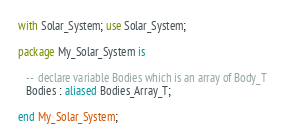Convert code to text. <code><loc_0><loc_0><loc_500><loc_500><_Ada_>with Solar_System; use Solar_System;

package My_Solar_System is

   --  declare variable Bodies which is an array of Body_T
   Bodies : aliased Bodies_Array_T;

end My_Solar_System;
</code> 